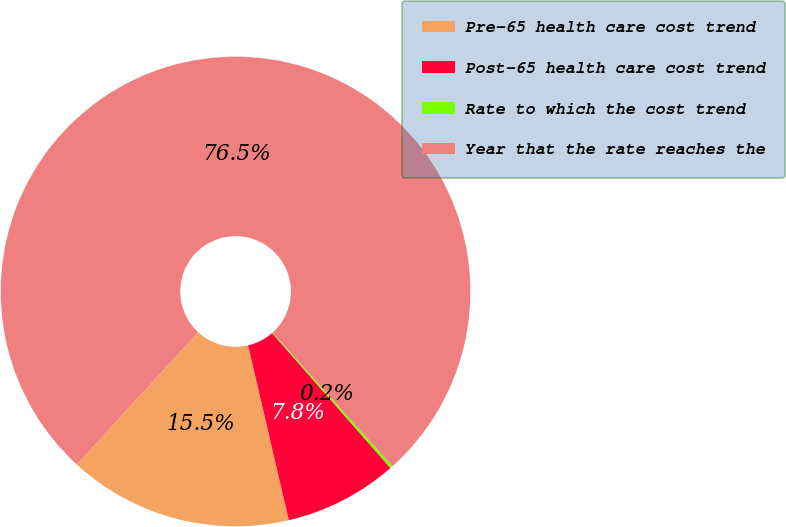Convert chart to OTSL. <chart><loc_0><loc_0><loc_500><loc_500><pie_chart><fcel>Pre-65 health care cost trend<fcel>Post-65 health care cost trend<fcel>Rate to which the cost trend<fcel>Year that the rate reaches the<nl><fcel>15.46%<fcel>7.82%<fcel>0.19%<fcel>76.53%<nl></chart> 